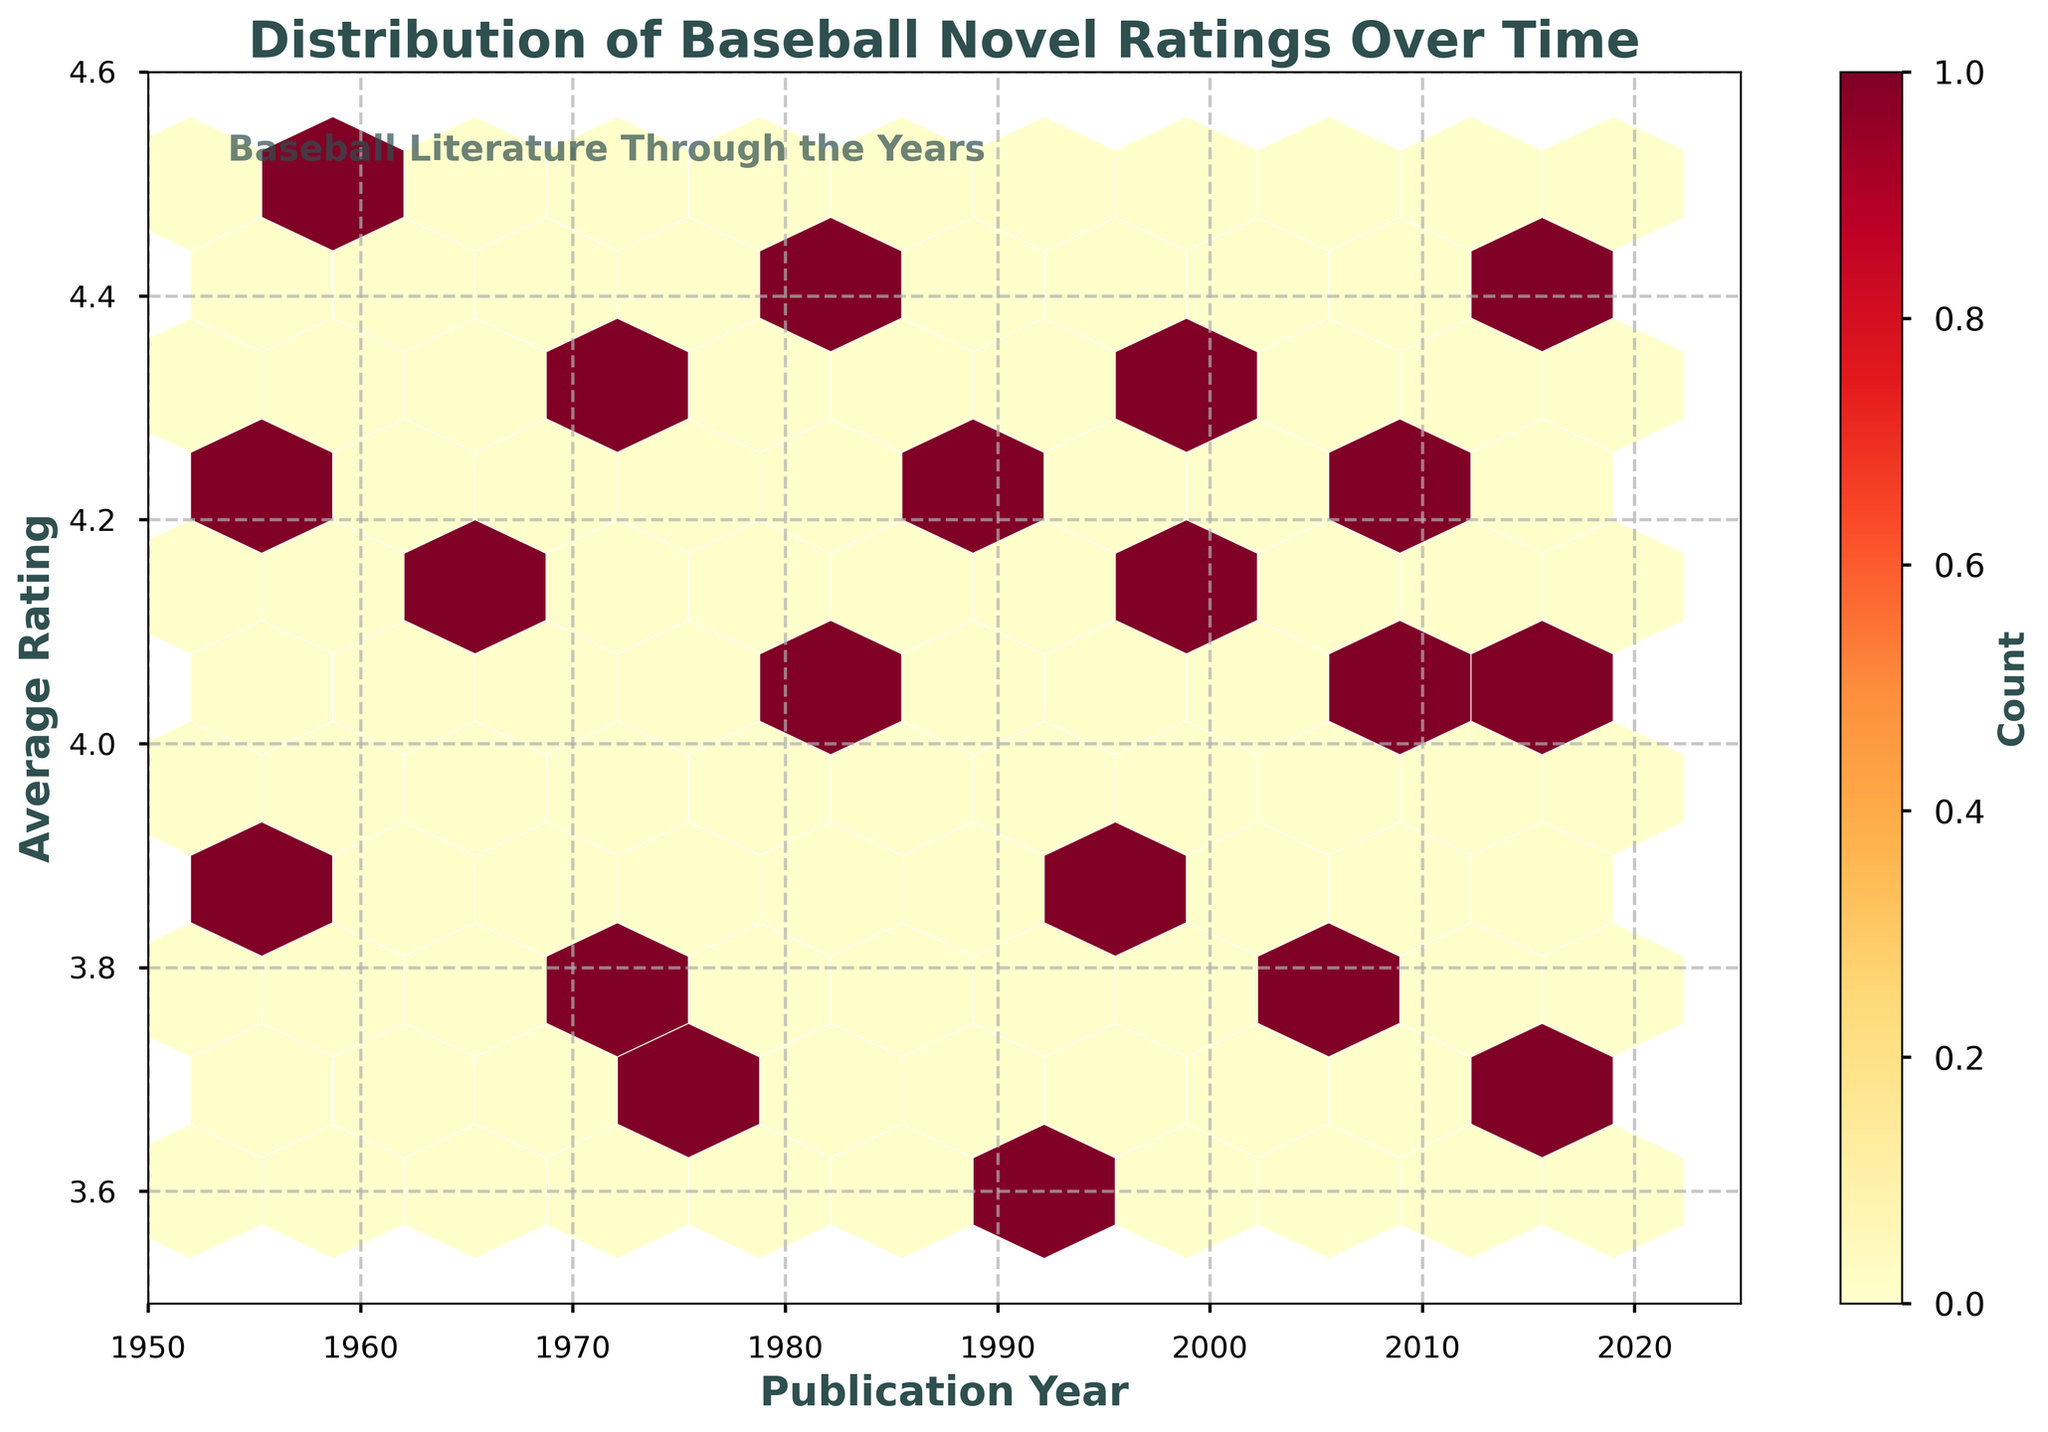What is the title of the figure? The title is prominently displayed at the top of the figure. It reads, "Distribution of Baseball Novel Ratings Over Time."
Answer: Distribution of Baseball Novel Ratings Over Time What is the time range displayed on the x-axis? The x-axis represents publication years ranging from 1950 to 2025, as shown by the axis ticks and labels.
Answer: 1950 to 2025 What is the range of average ratings on the y-axis? The y-axis displays average ratings from 3.5 to 4.6, as indicated by the axis ticks and labels.
Answer: 3.5 to 4.6 How many data points are marked around the year 2002? Around the year 2002, the hexbin plot shows a concentration of at least one hexagon. Since each hexagon represents multiple data points, the color intensity can help approximate counts.
Answer: At least 1 hexagon What color represents the highest density of data points? The hexbin plot uses a color gradient where the highest density of data points is shown in the darkest shade within the color map, which is a deep orange-red.
Answer: Deep orange-red What can you say about the overall trend in average ratings over the years? To determine the overall trend, observe the positions of hexagons over time. There is no specific linear trend, but average ratings mostly fluctuate between 3.6 and 4.4 across the years.
Answer: Fluctuates between 3.6 and 4.4 Which period shows the highest concentration of high average ratings (above 4.0)? High average ratings (above 4.0) can be identified by observing the vertical distribution of darker hexagons. There appears a higher concentration during the periods around 1960, 1973, and recent years around 2019.
Answer: About 1960, 1973, and 2019 Is there a period with few or no publications below an average rating of 3.8? Scan the hexbin plot for lighter colored or missing hexagons below the 3.8 rating mark. There is a noticeable absence of lower-rating hexagons primarily in the 1970s and early 2000s.
Answer: 1970s and early 2000s How does the average rating distribution for publications before 1980 compare to those after 1980? For comparison, look at the hexagon densities and heights before and after 1980. Before 1980, ratings tend to be higher with more concentrations above 4.0, whereas after 1980, there is a mix with more ratings below 4.0.
Answer: Higher before 1980, more mixed after 1980 